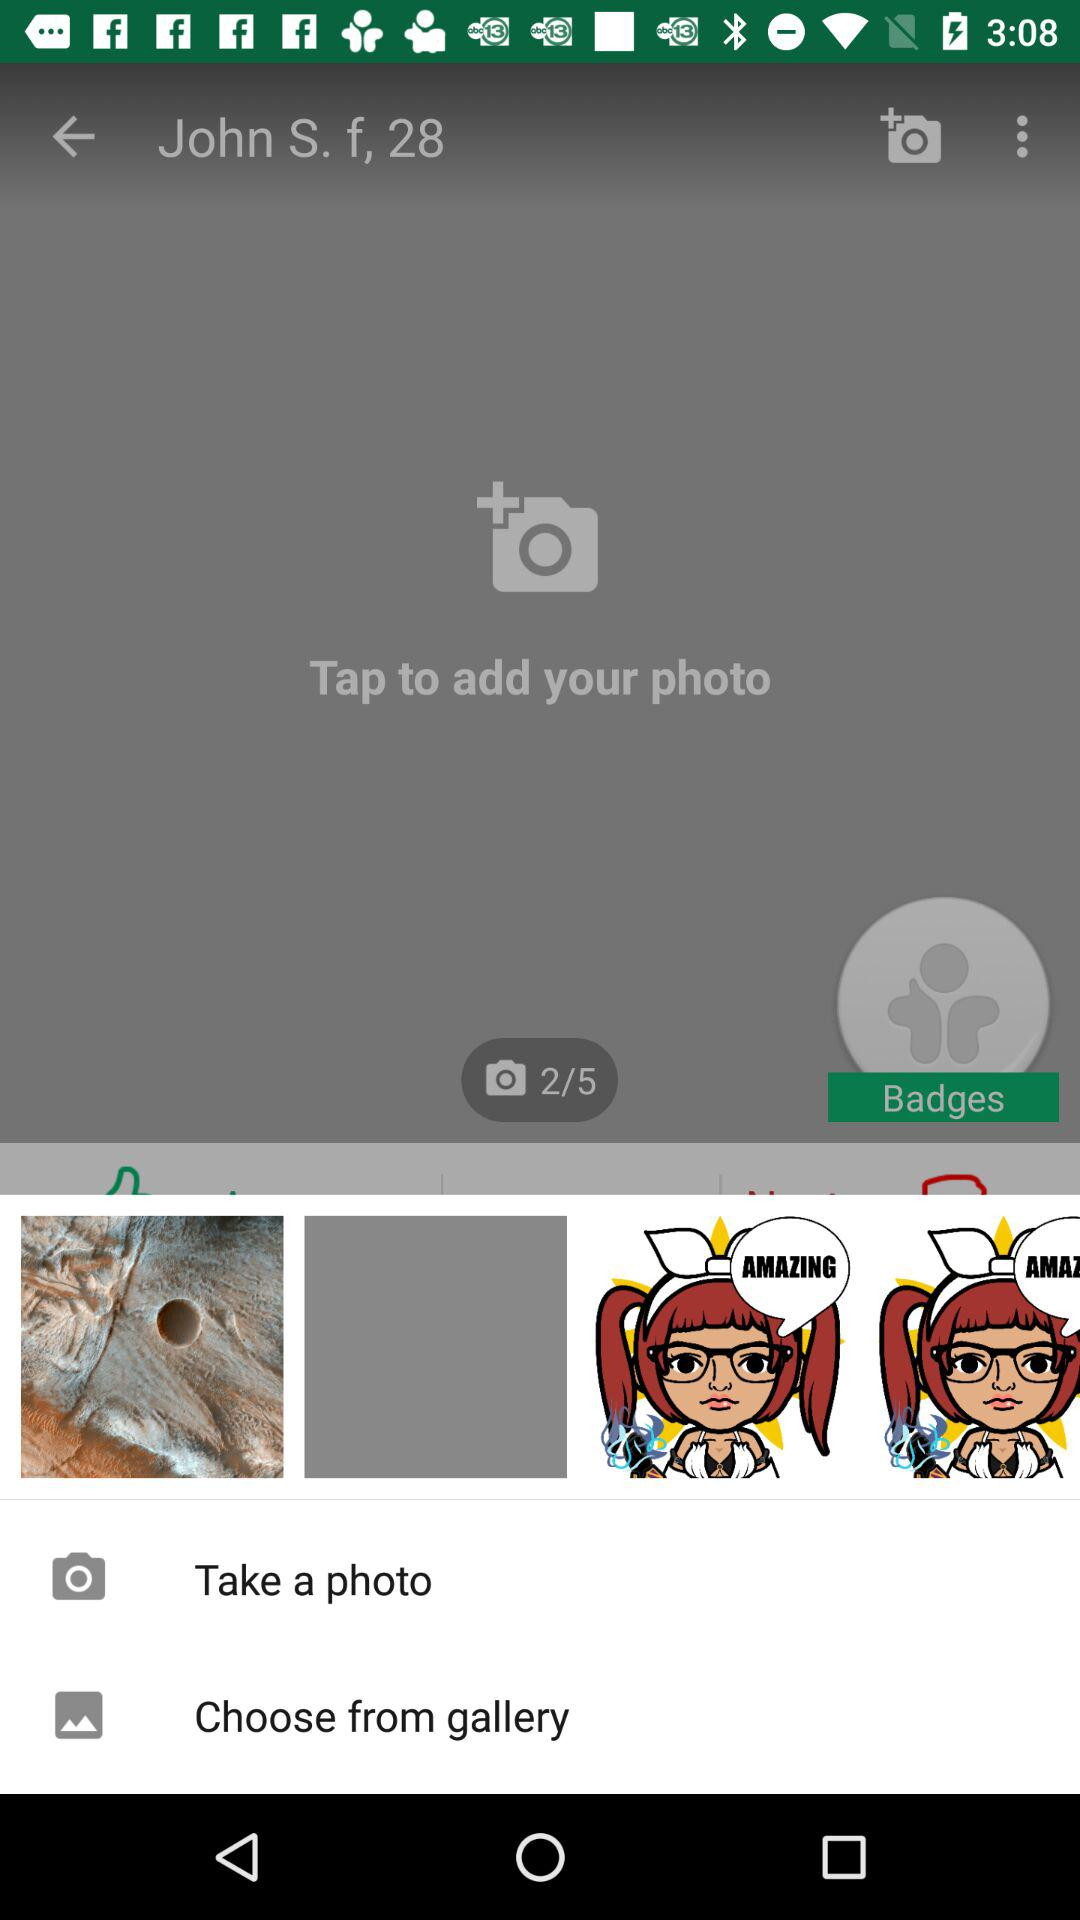What's the total number of photos we can upload? You can upload a total of 5 photos. 